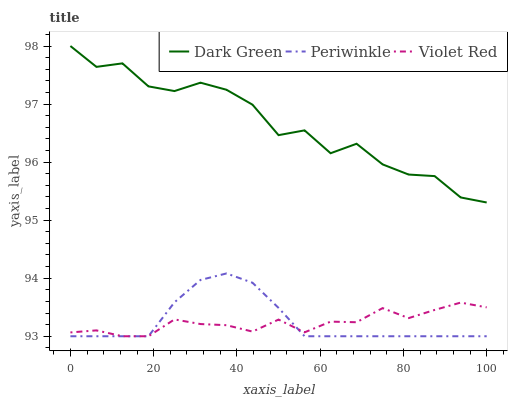Does Violet Red have the minimum area under the curve?
Answer yes or no. Yes. Does Periwinkle have the minimum area under the curve?
Answer yes or no. No. Does Periwinkle have the maximum area under the curve?
Answer yes or no. No. Is Dark Green the smoothest?
Answer yes or no. No. Is Periwinkle the roughest?
Answer yes or no. No. Does Dark Green have the lowest value?
Answer yes or no. No. Does Periwinkle have the highest value?
Answer yes or no. No. Is Violet Red less than Dark Green?
Answer yes or no. Yes. Is Dark Green greater than Periwinkle?
Answer yes or no. Yes. Does Violet Red intersect Dark Green?
Answer yes or no. No. 